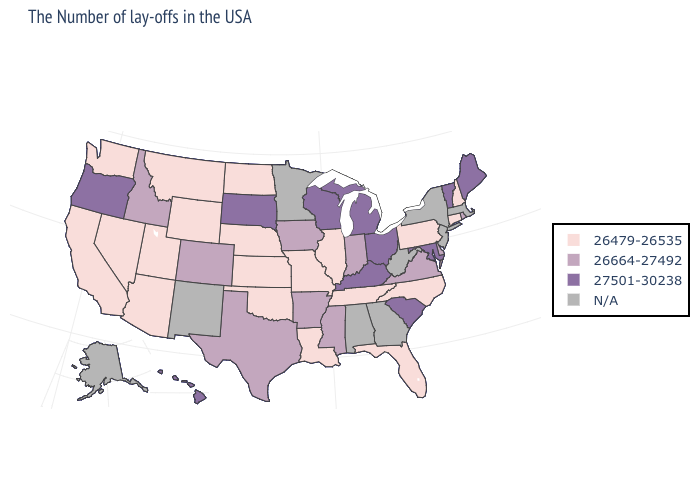Which states have the lowest value in the MidWest?
Concise answer only. Illinois, Missouri, Kansas, Nebraska, North Dakota. Name the states that have a value in the range 26479-26535?
Short answer required. New Hampshire, Connecticut, Pennsylvania, North Carolina, Florida, Tennessee, Illinois, Louisiana, Missouri, Kansas, Nebraska, Oklahoma, North Dakota, Wyoming, Utah, Montana, Arizona, Nevada, California, Washington. Name the states that have a value in the range N/A?
Quick response, please. Massachusetts, New York, New Jersey, West Virginia, Georgia, Alabama, Minnesota, New Mexico, Alaska. Among the states that border Idaho , does Oregon have the highest value?
Answer briefly. Yes. Name the states that have a value in the range 26664-27492?
Be succinct. Rhode Island, Delaware, Virginia, Indiana, Mississippi, Arkansas, Iowa, Texas, Colorado, Idaho. Name the states that have a value in the range 26479-26535?
Answer briefly. New Hampshire, Connecticut, Pennsylvania, North Carolina, Florida, Tennessee, Illinois, Louisiana, Missouri, Kansas, Nebraska, Oklahoma, North Dakota, Wyoming, Utah, Montana, Arizona, Nevada, California, Washington. Name the states that have a value in the range N/A?
Keep it brief. Massachusetts, New York, New Jersey, West Virginia, Georgia, Alabama, Minnesota, New Mexico, Alaska. Is the legend a continuous bar?
Keep it brief. No. What is the lowest value in states that border New Hampshire?
Keep it brief. 27501-30238. Which states have the highest value in the USA?
Quick response, please. Maine, Vermont, Maryland, South Carolina, Ohio, Michigan, Kentucky, Wisconsin, South Dakota, Oregon, Hawaii. What is the value of Montana?
Be succinct. 26479-26535. Name the states that have a value in the range 27501-30238?
Give a very brief answer. Maine, Vermont, Maryland, South Carolina, Ohio, Michigan, Kentucky, Wisconsin, South Dakota, Oregon, Hawaii. What is the value of Idaho?
Concise answer only. 26664-27492. Name the states that have a value in the range 26479-26535?
Give a very brief answer. New Hampshire, Connecticut, Pennsylvania, North Carolina, Florida, Tennessee, Illinois, Louisiana, Missouri, Kansas, Nebraska, Oklahoma, North Dakota, Wyoming, Utah, Montana, Arizona, Nevada, California, Washington. Does the map have missing data?
Be succinct. Yes. 